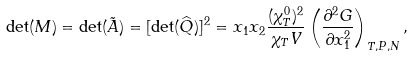<formula> <loc_0><loc_0><loc_500><loc_500>\det ( M ) = \det ( \tilde { A } ) = [ \det ( \widehat { Q } ) ] ^ { 2 } = x _ { 1 } x _ { 2 } \frac { ( \chi _ { T } ^ { 0 } ) ^ { 2 } } { \chi _ { T } V } \left ( \frac { \partial ^ { 2 } G } { \partial x _ { 1 } ^ { 2 } } \right ) _ { T , P , N } ,</formula> 